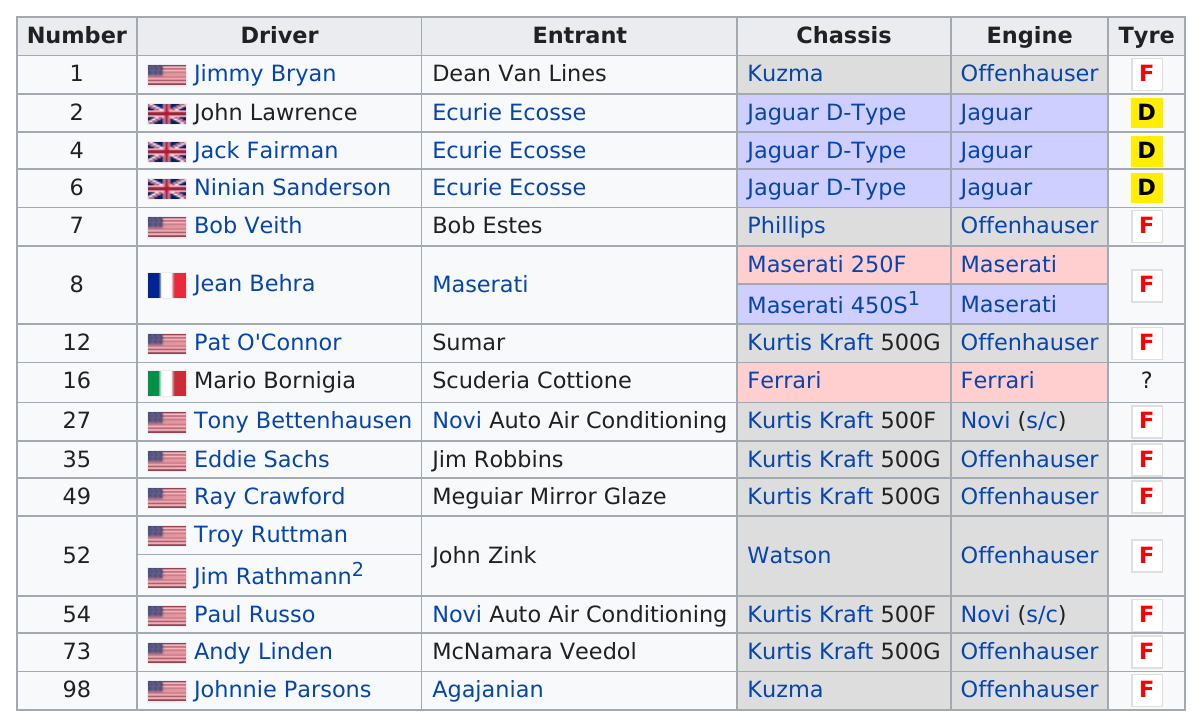Identify some key points in this picture. Johnnie Parsons was the last driver on the list. Jean Behra is listed above Bob Veith. Troy Ruttman was entered by the same person as Jim Rathmann, the other driver. Ferrari was the only engine that was used only once. The last person to enter the race was Johnnie Parsons. 